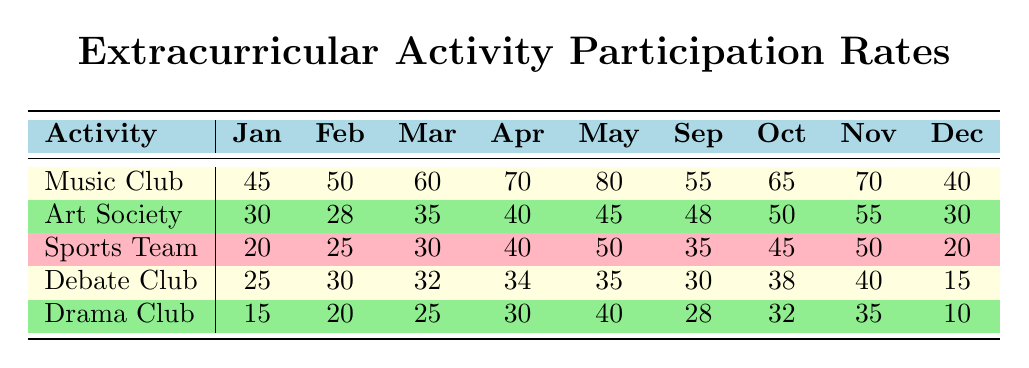What is the participation rate of the Music Club in May? The participation rate for the Music Club in May is listed in the table under the May column for Music Club, which is 80.
Answer: 80 Which activity had the lowest participation rate in December? Looking at the December column under each activity, the lowest rate is for the Drama Club, which has a participation rate of 10.
Answer: Drama Club What is the total participation rate for the Sports Team across all months? To find the total participation rate for the Sports Team, we add the participation rates from each month: 20 + 25 + 30 + 40 + 50 + 35 + 45 + 50 + 20 = 315.
Answer: 315 Was there an increase in participation for the Debate Club from January to April? In the table, the participation rates for the Debate Club from January to April are 25, 30, 32, and 34 respectively. Each month shows an increase, confirming there is an increase from January to April.
Answer: Yes What is the average participation rate for the Art Society over the months provided? To calculate the average participation rate for the Art Society, sum the rates for each month: 30 + 28 + 35 + 40 + 45 + 48 + 50 + 55 + 30 = 361. There are 9 months, so the average is 361/9 = 40.11 (or approximately 40).
Answer: 40.11 How did the participation rate for the Drama Club compare from February to November? In February, the participation rate for the Drama Club is 20, while in November it is 35. This shows an increase of 15 from February to November.
Answer: It increased by 15 Which extracurricular activity had the highest participation rate in September? Looking at the September column, I see that the Music Club has the highest participation rate of 55 compared to other activities for that month.
Answer: Music Club Did any activities have a participation rate of 40 in April? Reviewing the April column, I find that three activities have a rate of 40: Music Club, Art Society, and Sports Team.
Answer: Yes, Music Club, Art Society, and Sports Team 